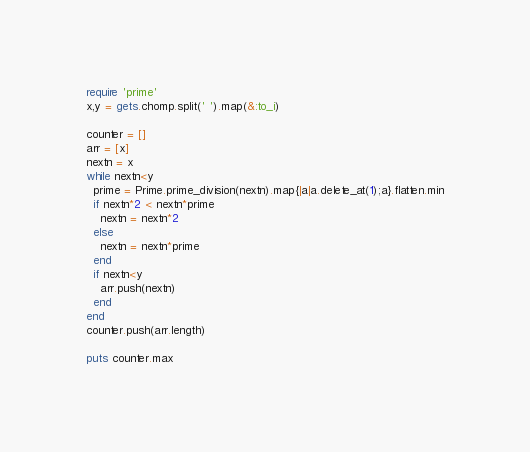Convert code to text. <code><loc_0><loc_0><loc_500><loc_500><_Ruby_>require 'prime'
x,y = gets.chomp.split(' ').map(&:to_i)

counter = []
arr = [x]
nextn = x
while nextn<y
  prime = Prime.prime_division(nextn).map{|a|a.delete_at(1);a}.flatten.min
  if nextn*2 < nextn*prime
    nextn = nextn*2
  else
    nextn = nextn*prime
  end
  if nextn<y
    arr.push(nextn)
  end
end
counter.push(arr.length)

puts counter.max</code> 